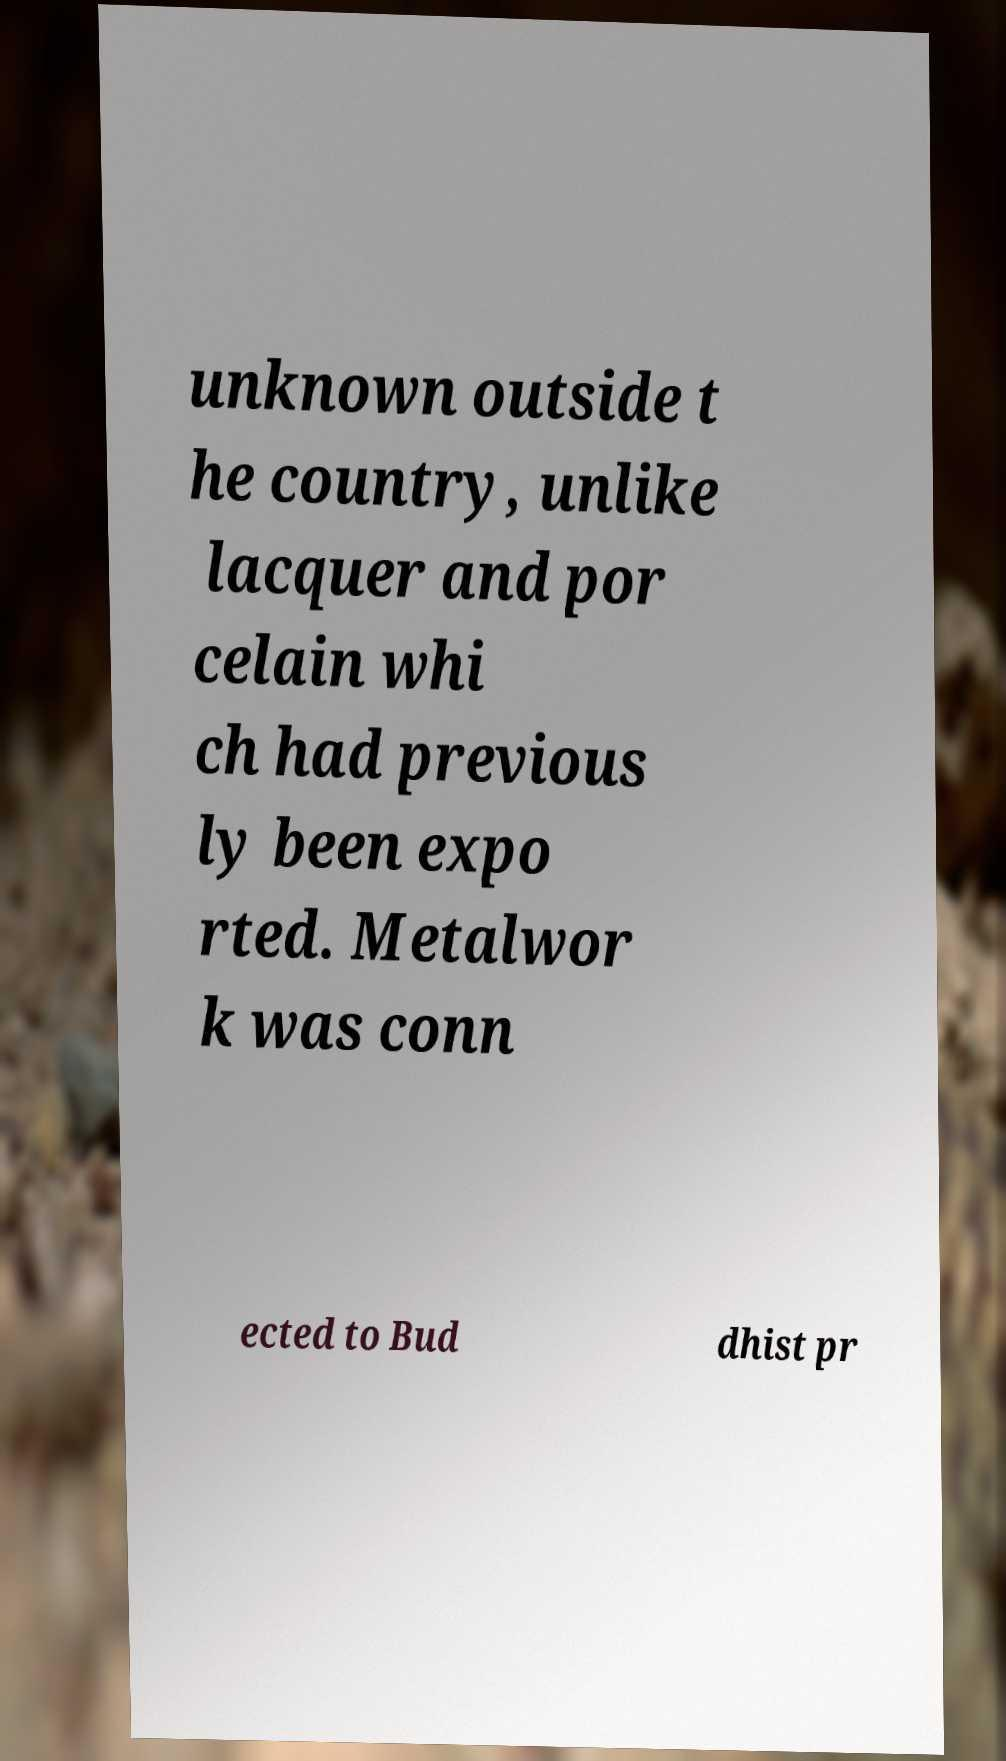What messages or text are displayed in this image? I need them in a readable, typed format. unknown outside t he country, unlike lacquer and por celain whi ch had previous ly been expo rted. Metalwor k was conn ected to Bud dhist pr 